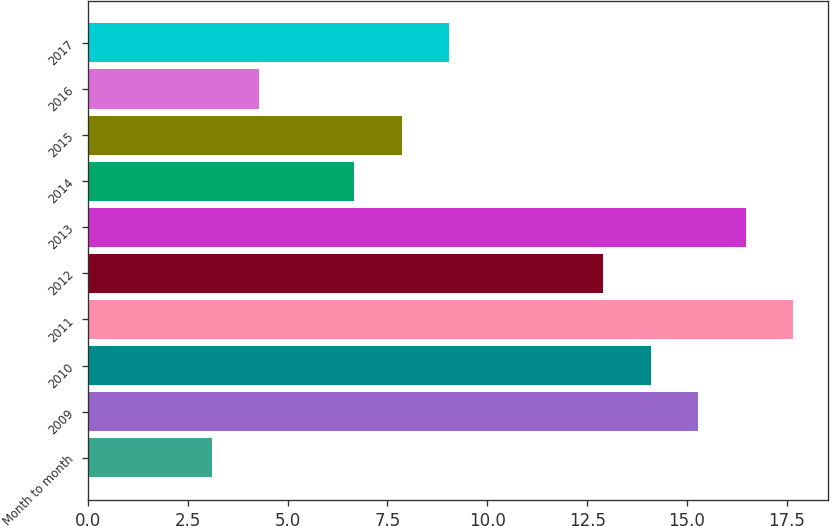<chart> <loc_0><loc_0><loc_500><loc_500><bar_chart><fcel>Month to month<fcel>2009<fcel>2010<fcel>2011<fcel>2012<fcel>2013<fcel>2014<fcel>2015<fcel>2016<fcel>2017<nl><fcel>3.1<fcel>15.28<fcel>14.09<fcel>17.66<fcel>12.9<fcel>16.47<fcel>6.67<fcel>7.86<fcel>4.29<fcel>9.05<nl></chart> 